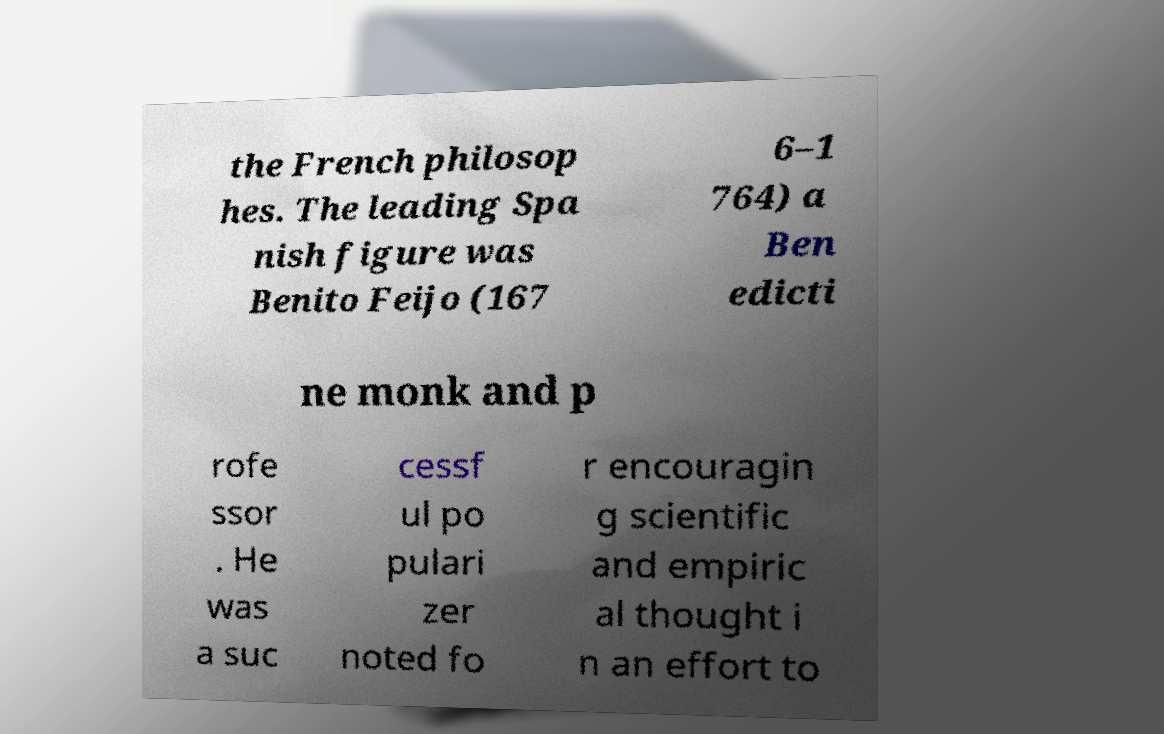Could you extract and type out the text from this image? the French philosop hes. The leading Spa nish figure was Benito Feijo (167 6–1 764) a Ben edicti ne monk and p rofe ssor . He was a suc cessf ul po pulari zer noted fo r encouragin g scientific and empiric al thought i n an effort to 